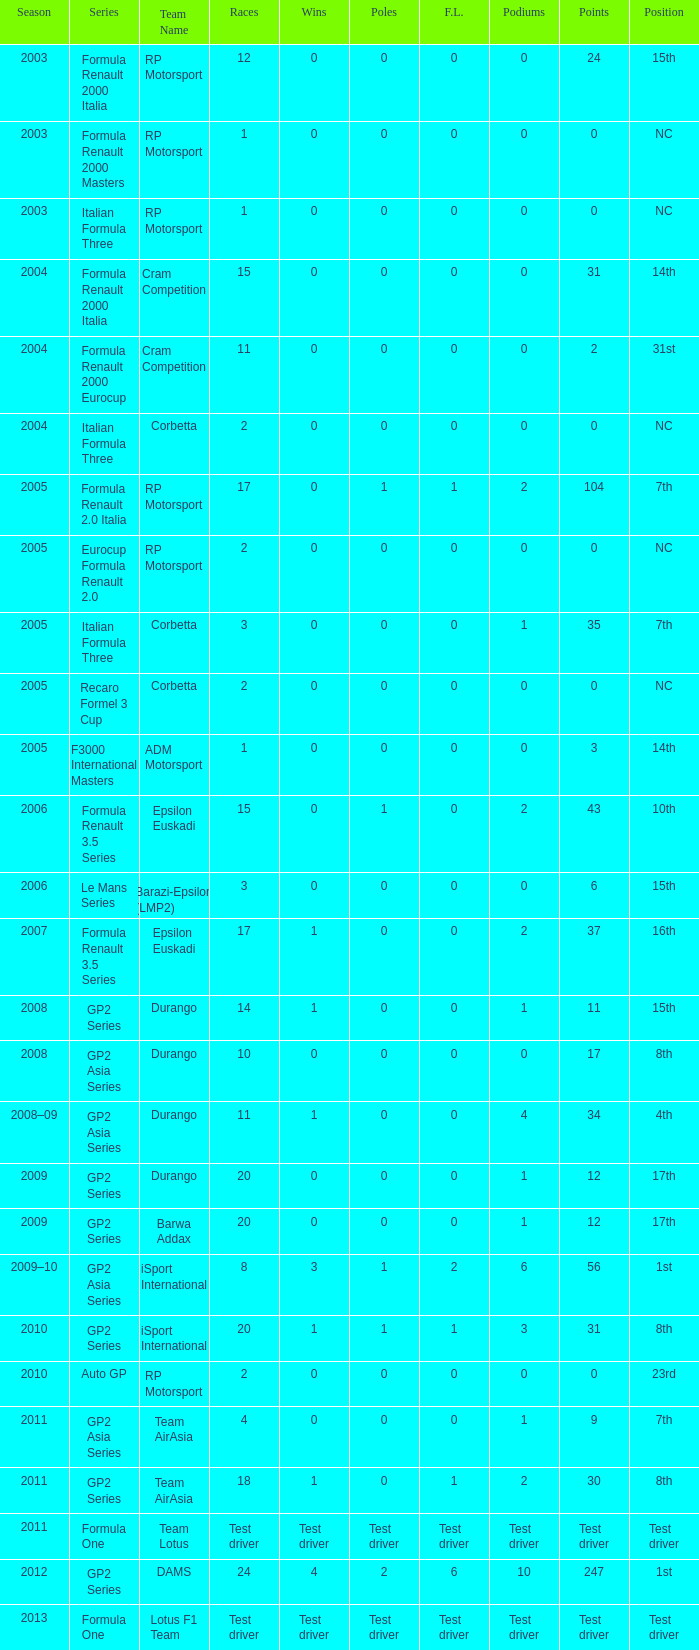What is the number of poles with 4 races? 0.0. 